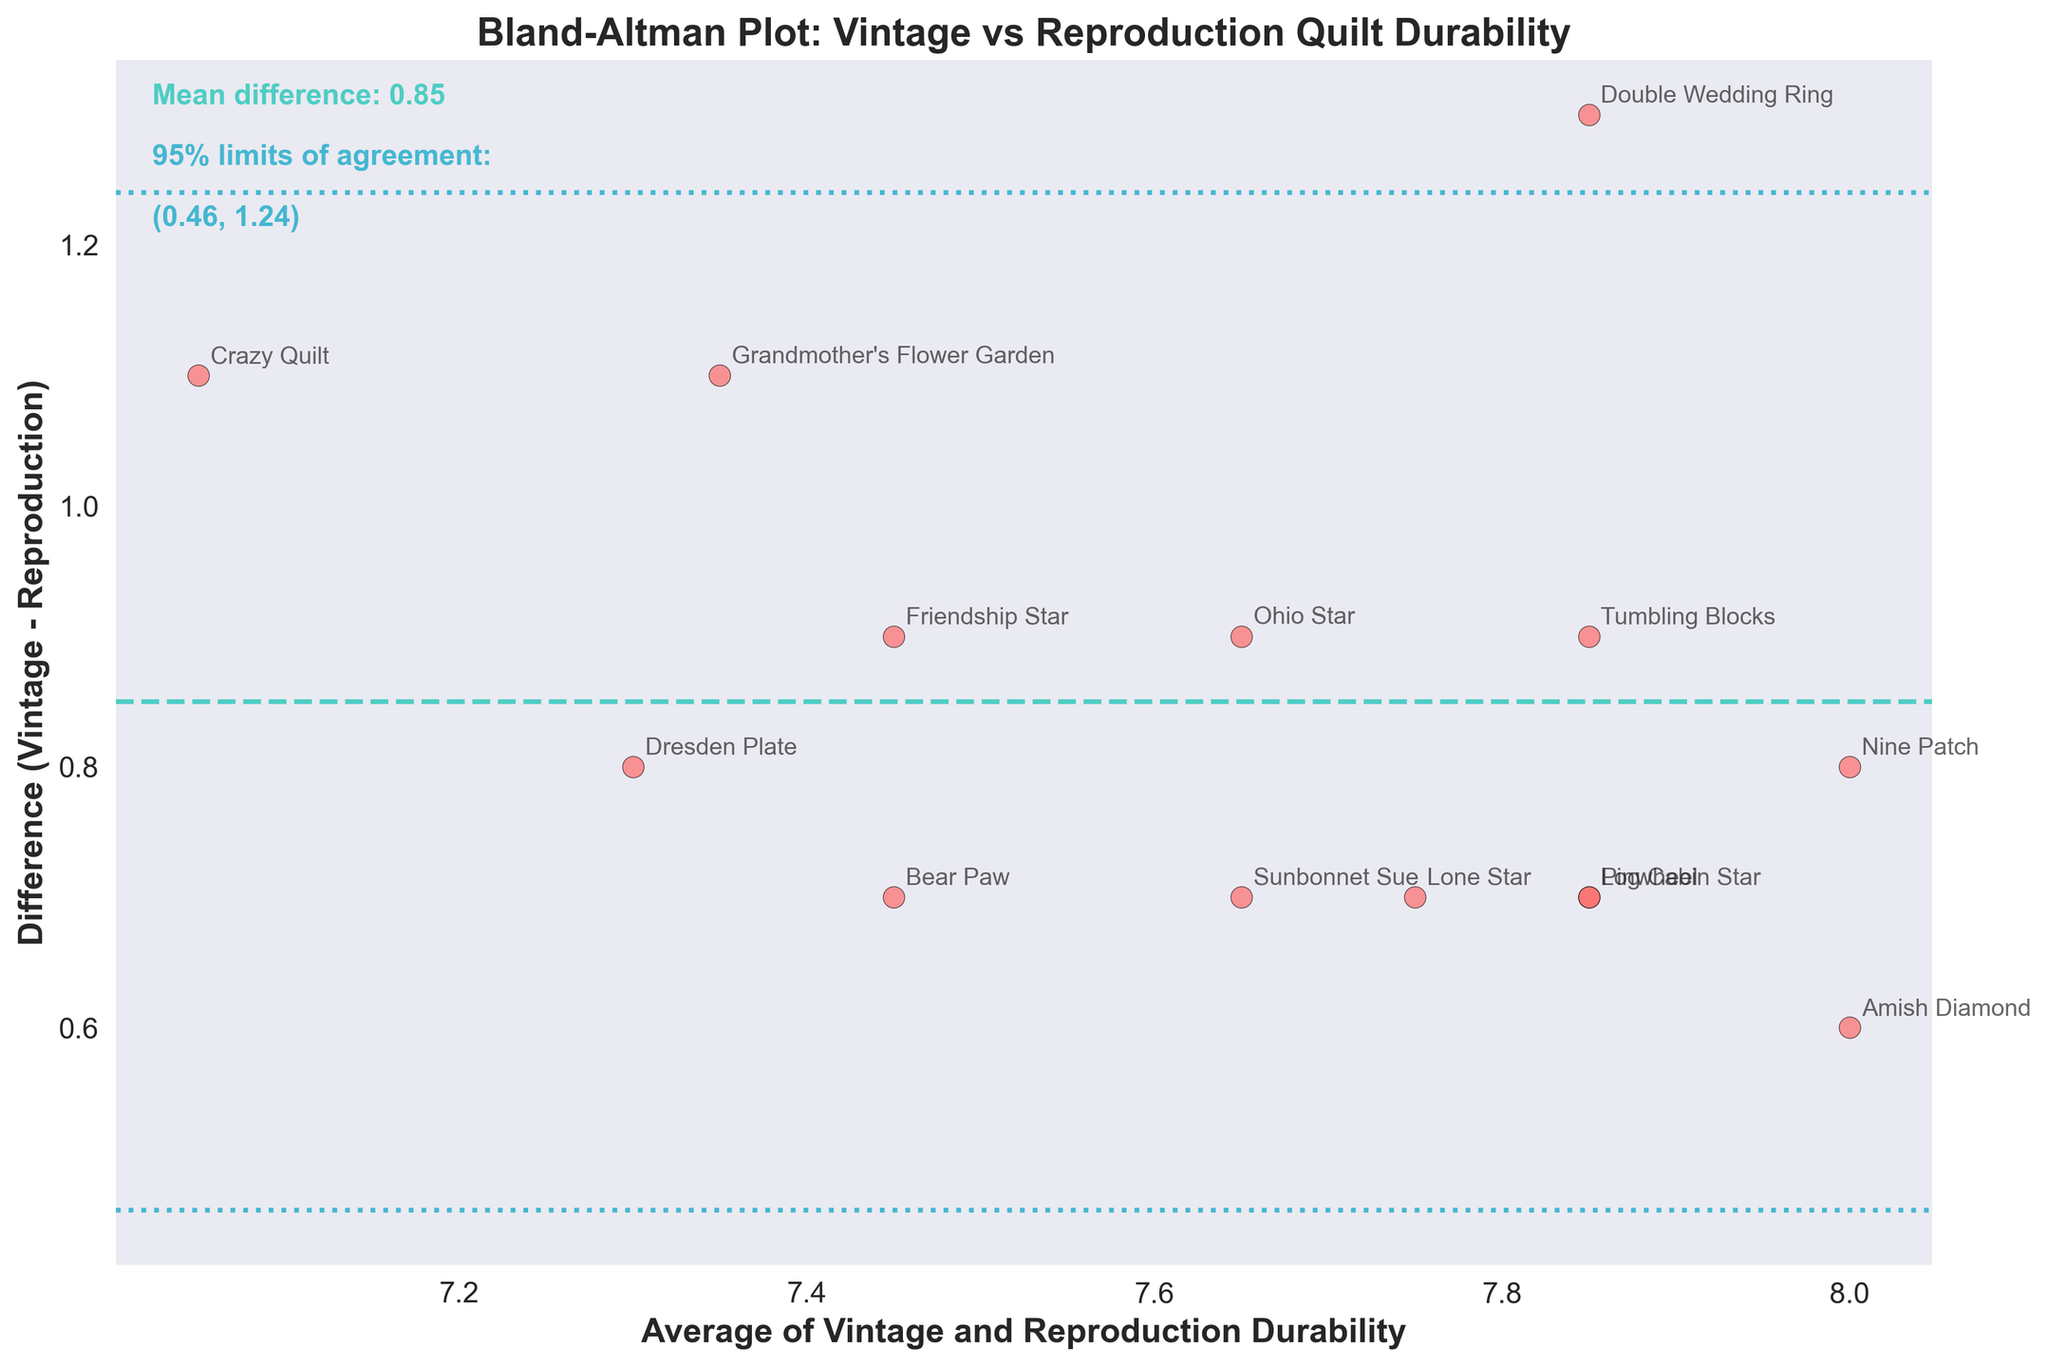What does the title of the plot indicate? The title is "Bland-Altman Plot: Vintage vs Reproduction Quilt Durability," which indicates that the plot compares the fabric durability ratings between modern reproductions and authentic vintage quilts and examines the discrepancies and averages between them.
Answer: Comparison of quilt durability What does the x-axis represent in the plot? The x-axis represents the "Average of Vintage and Reproduction Durability," which is the mean durability rating of both vintage and reproduction quilts for each name.
Answer: Average durability What does the y-axis represent in the plot? The y-axis represents the "Difference (Vintage - Reproduction)," showing how vintage and reproduction durability ratings differ for each quilt.
Answer: Difference in durability How many quilts were analyzed in the plot? There are 14 data points, each marked by a scatter point with quilt names annotated next to them.
Answer: 14 quilts What is the mean difference between vintage and reproduction durability? The mean difference is shown as a dashed line in the plot, indicated by a text annotation.
Answer: -0.86 What are the upper and lower limits of agreement, and how are they visually represented in the plot? The limits of agreement are lines drawn at the mean difference plus and minus 1.96 times the standard deviation of the differences, displayed as dotted lines with text annotations.
Answer: (-1.50, -0.22) Which quilt has the highest positive difference in durability between vintage and reproduction, and what is its value? The "Grandmother's Flower Garden" has the highest positive difference in durability, which is visible on the plot where it is annotated farthest above the mean difference line.
Answer: 1.1 Which quilt has the lowest negative difference in durability between vintage and reproduction, and what is its value? "Crazy Quilt" is the quilt that has the highest negative difference in durability, marked below the mean difference line.
Answer: -1.1 How does the durability of the "Grandmother's Flower Garden" compare to its vintage counterpart? Refer to the plot and identify the average for "Grandmother's Flower Garden" and its position along the y-axis. The point is above the mean difference line, showing the vintage is higher.
Answer: Vintage is more durable by 1.1 What can we infer if many data points lie outside the limits of agreement? When data points are outside the limits of agreement, it indicates significant discrepancies between vintage and reproduction durability ratings for those quilts, suggesting inconsistencies or varying quality in reproductions.
Answer: Significant discrepancies 